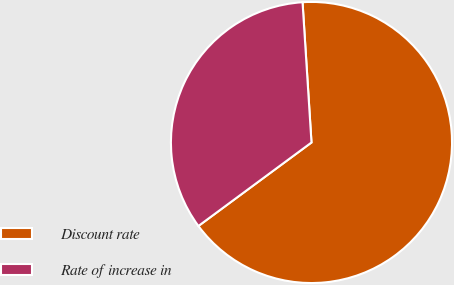Convert chart. <chart><loc_0><loc_0><loc_500><loc_500><pie_chart><fcel>Discount rate<fcel>Rate of increase in<nl><fcel>65.89%<fcel>34.11%<nl></chart> 